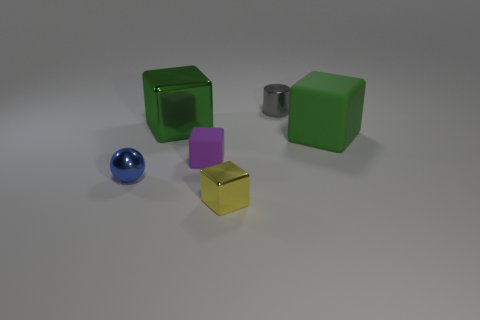Add 4 small metallic cubes. How many objects exist? 10 Subtract all spheres. How many objects are left? 5 Add 6 rubber objects. How many rubber objects exist? 8 Subtract 0 red cubes. How many objects are left? 6 Subtract all green objects. Subtract all big metal things. How many objects are left? 3 Add 5 large green things. How many large green things are left? 7 